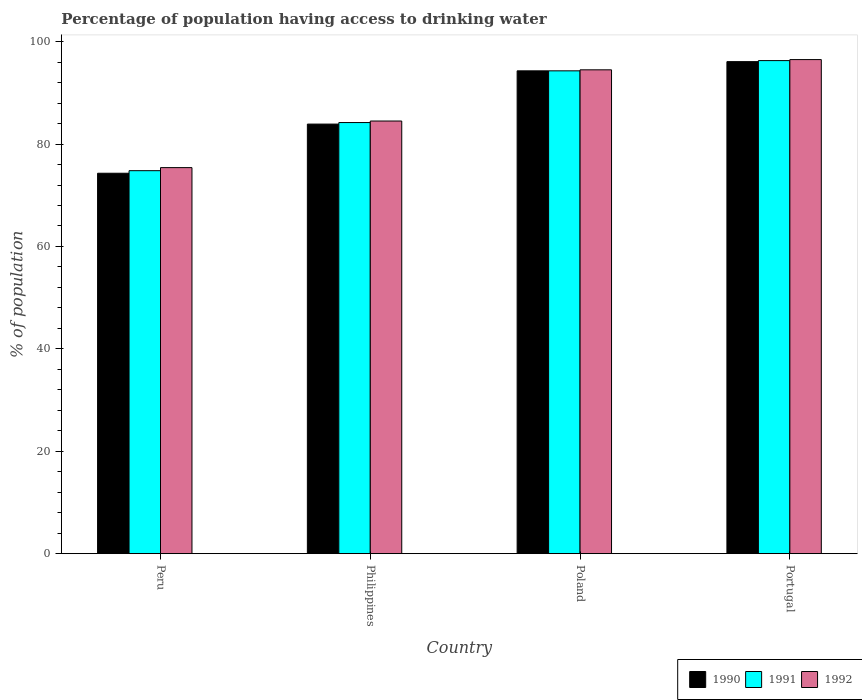How many groups of bars are there?
Your response must be concise. 4. Are the number of bars on each tick of the X-axis equal?
Your answer should be compact. Yes. What is the percentage of population having access to drinking water in 1990 in Portugal?
Give a very brief answer. 96.1. Across all countries, what is the maximum percentage of population having access to drinking water in 1991?
Ensure brevity in your answer.  96.3. Across all countries, what is the minimum percentage of population having access to drinking water in 1992?
Offer a very short reply. 75.4. In which country was the percentage of population having access to drinking water in 1991 maximum?
Give a very brief answer. Portugal. In which country was the percentage of population having access to drinking water in 1991 minimum?
Make the answer very short. Peru. What is the total percentage of population having access to drinking water in 1990 in the graph?
Offer a terse response. 348.6. What is the difference between the percentage of population having access to drinking water in 1990 in Philippines and that in Portugal?
Make the answer very short. -12.2. What is the difference between the percentage of population having access to drinking water in 1990 in Portugal and the percentage of population having access to drinking water in 1992 in Philippines?
Offer a very short reply. 11.6. What is the average percentage of population having access to drinking water in 1992 per country?
Keep it short and to the point. 87.72. What is the difference between the percentage of population having access to drinking water of/in 1992 and percentage of population having access to drinking water of/in 1991 in Peru?
Your response must be concise. 0.6. What is the ratio of the percentage of population having access to drinking water in 1991 in Peru to that in Poland?
Keep it short and to the point. 0.79. What is the difference between the highest and the lowest percentage of population having access to drinking water in 1990?
Give a very brief answer. 21.8. Is the sum of the percentage of population having access to drinking water in 1991 in Philippines and Portugal greater than the maximum percentage of population having access to drinking water in 1990 across all countries?
Make the answer very short. Yes. Is it the case that in every country, the sum of the percentage of population having access to drinking water in 1990 and percentage of population having access to drinking water in 1991 is greater than the percentage of population having access to drinking water in 1992?
Give a very brief answer. Yes. Are all the bars in the graph horizontal?
Your response must be concise. No. How many countries are there in the graph?
Your answer should be very brief. 4. How are the legend labels stacked?
Your response must be concise. Horizontal. What is the title of the graph?
Make the answer very short. Percentage of population having access to drinking water. Does "1988" appear as one of the legend labels in the graph?
Offer a terse response. No. What is the label or title of the Y-axis?
Your answer should be very brief. % of population. What is the % of population of 1990 in Peru?
Make the answer very short. 74.3. What is the % of population in 1991 in Peru?
Offer a terse response. 74.8. What is the % of population in 1992 in Peru?
Provide a short and direct response. 75.4. What is the % of population in 1990 in Philippines?
Give a very brief answer. 83.9. What is the % of population of 1991 in Philippines?
Your response must be concise. 84.2. What is the % of population of 1992 in Philippines?
Your answer should be compact. 84.5. What is the % of population of 1990 in Poland?
Keep it short and to the point. 94.3. What is the % of population of 1991 in Poland?
Your answer should be compact. 94.3. What is the % of population in 1992 in Poland?
Your answer should be very brief. 94.5. What is the % of population in 1990 in Portugal?
Your response must be concise. 96.1. What is the % of population in 1991 in Portugal?
Your response must be concise. 96.3. What is the % of population in 1992 in Portugal?
Provide a succinct answer. 96.5. Across all countries, what is the maximum % of population in 1990?
Keep it short and to the point. 96.1. Across all countries, what is the maximum % of population in 1991?
Offer a very short reply. 96.3. Across all countries, what is the maximum % of population in 1992?
Your answer should be very brief. 96.5. Across all countries, what is the minimum % of population of 1990?
Provide a short and direct response. 74.3. Across all countries, what is the minimum % of population in 1991?
Ensure brevity in your answer.  74.8. Across all countries, what is the minimum % of population in 1992?
Give a very brief answer. 75.4. What is the total % of population in 1990 in the graph?
Offer a terse response. 348.6. What is the total % of population in 1991 in the graph?
Give a very brief answer. 349.6. What is the total % of population of 1992 in the graph?
Your answer should be compact. 350.9. What is the difference between the % of population in 1990 in Peru and that in Philippines?
Keep it short and to the point. -9.6. What is the difference between the % of population in 1991 in Peru and that in Philippines?
Give a very brief answer. -9.4. What is the difference between the % of population in 1992 in Peru and that in Philippines?
Your answer should be compact. -9.1. What is the difference between the % of population of 1991 in Peru and that in Poland?
Give a very brief answer. -19.5. What is the difference between the % of population of 1992 in Peru and that in Poland?
Make the answer very short. -19.1. What is the difference between the % of population of 1990 in Peru and that in Portugal?
Your answer should be very brief. -21.8. What is the difference between the % of population of 1991 in Peru and that in Portugal?
Provide a succinct answer. -21.5. What is the difference between the % of population in 1992 in Peru and that in Portugal?
Provide a short and direct response. -21.1. What is the difference between the % of population in 1991 in Philippines and that in Poland?
Your answer should be very brief. -10.1. What is the difference between the % of population in 1992 in Philippines and that in Poland?
Offer a very short reply. -10. What is the difference between the % of population of 1991 in Philippines and that in Portugal?
Offer a terse response. -12.1. What is the difference between the % of population of 1990 in Poland and that in Portugal?
Keep it short and to the point. -1.8. What is the difference between the % of population in 1991 in Poland and that in Portugal?
Ensure brevity in your answer.  -2. What is the difference between the % of population in 1991 in Peru and the % of population in 1992 in Philippines?
Make the answer very short. -9.7. What is the difference between the % of population in 1990 in Peru and the % of population in 1991 in Poland?
Your answer should be very brief. -20. What is the difference between the % of population of 1990 in Peru and the % of population of 1992 in Poland?
Offer a terse response. -20.2. What is the difference between the % of population in 1991 in Peru and the % of population in 1992 in Poland?
Offer a terse response. -19.7. What is the difference between the % of population of 1990 in Peru and the % of population of 1991 in Portugal?
Your response must be concise. -22. What is the difference between the % of population of 1990 in Peru and the % of population of 1992 in Portugal?
Offer a very short reply. -22.2. What is the difference between the % of population in 1991 in Peru and the % of population in 1992 in Portugal?
Make the answer very short. -21.7. What is the difference between the % of population in 1990 in Philippines and the % of population in 1992 in Poland?
Make the answer very short. -10.6. What is the difference between the % of population in 1991 in Philippines and the % of population in 1992 in Poland?
Provide a succinct answer. -10.3. What is the difference between the % of population of 1990 in Philippines and the % of population of 1991 in Portugal?
Your answer should be very brief. -12.4. What is the difference between the % of population in 1990 in Philippines and the % of population in 1992 in Portugal?
Offer a very short reply. -12.6. What is the difference between the % of population of 1990 in Poland and the % of population of 1991 in Portugal?
Ensure brevity in your answer.  -2. What is the difference between the % of population in 1990 in Poland and the % of population in 1992 in Portugal?
Your answer should be very brief. -2.2. What is the average % of population in 1990 per country?
Your answer should be compact. 87.15. What is the average % of population of 1991 per country?
Give a very brief answer. 87.4. What is the average % of population of 1992 per country?
Offer a terse response. 87.72. What is the difference between the % of population of 1991 and % of population of 1992 in Peru?
Keep it short and to the point. -0.6. What is the difference between the % of population in 1990 and % of population in 1991 in Poland?
Your response must be concise. 0. What is the difference between the % of population of 1990 and % of population of 1992 in Poland?
Make the answer very short. -0.2. What is the difference between the % of population in 1990 and % of population in 1991 in Portugal?
Provide a short and direct response. -0.2. What is the difference between the % of population of 1990 and % of population of 1992 in Portugal?
Offer a very short reply. -0.4. What is the ratio of the % of population of 1990 in Peru to that in Philippines?
Your response must be concise. 0.89. What is the ratio of the % of population in 1991 in Peru to that in Philippines?
Give a very brief answer. 0.89. What is the ratio of the % of population of 1992 in Peru to that in Philippines?
Your answer should be very brief. 0.89. What is the ratio of the % of population in 1990 in Peru to that in Poland?
Give a very brief answer. 0.79. What is the ratio of the % of population in 1991 in Peru to that in Poland?
Your answer should be very brief. 0.79. What is the ratio of the % of population in 1992 in Peru to that in Poland?
Your answer should be compact. 0.8. What is the ratio of the % of population in 1990 in Peru to that in Portugal?
Give a very brief answer. 0.77. What is the ratio of the % of population of 1991 in Peru to that in Portugal?
Your answer should be very brief. 0.78. What is the ratio of the % of population in 1992 in Peru to that in Portugal?
Keep it short and to the point. 0.78. What is the ratio of the % of population of 1990 in Philippines to that in Poland?
Keep it short and to the point. 0.89. What is the ratio of the % of population of 1991 in Philippines to that in Poland?
Offer a very short reply. 0.89. What is the ratio of the % of population of 1992 in Philippines to that in Poland?
Your response must be concise. 0.89. What is the ratio of the % of population of 1990 in Philippines to that in Portugal?
Offer a very short reply. 0.87. What is the ratio of the % of population of 1991 in Philippines to that in Portugal?
Provide a short and direct response. 0.87. What is the ratio of the % of population in 1992 in Philippines to that in Portugal?
Give a very brief answer. 0.88. What is the ratio of the % of population in 1990 in Poland to that in Portugal?
Provide a short and direct response. 0.98. What is the ratio of the % of population in 1991 in Poland to that in Portugal?
Offer a terse response. 0.98. What is the ratio of the % of population in 1992 in Poland to that in Portugal?
Give a very brief answer. 0.98. What is the difference between the highest and the second highest % of population of 1990?
Provide a succinct answer. 1.8. What is the difference between the highest and the second highest % of population of 1992?
Offer a terse response. 2. What is the difference between the highest and the lowest % of population in 1990?
Provide a succinct answer. 21.8. What is the difference between the highest and the lowest % of population in 1992?
Your answer should be very brief. 21.1. 